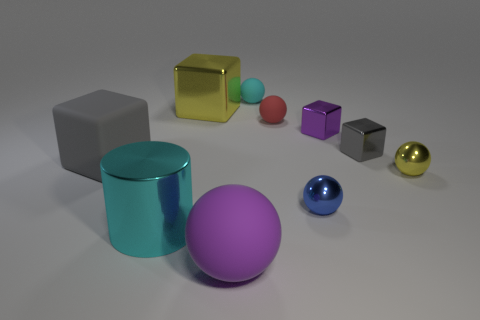Subtract 1 spheres. How many spheres are left? 4 Subtract all metal cubes. How many cubes are left? 1 Subtract all purple balls. How many balls are left? 4 Subtract all blue spheres. Subtract all cyan cubes. How many spheres are left? 4 Subtract all blocks. How many objects are left? 6 Add 3 large purple things. How many large purple things exist? 4 Subtract 0 brown cylinders. How many objects are left? 10 Subtract all large brown cubes. Subtract all small gray shiny things. How many objects are left? 9 Add 7 purple matte spheres. How many purple matte spheres are left? 8 